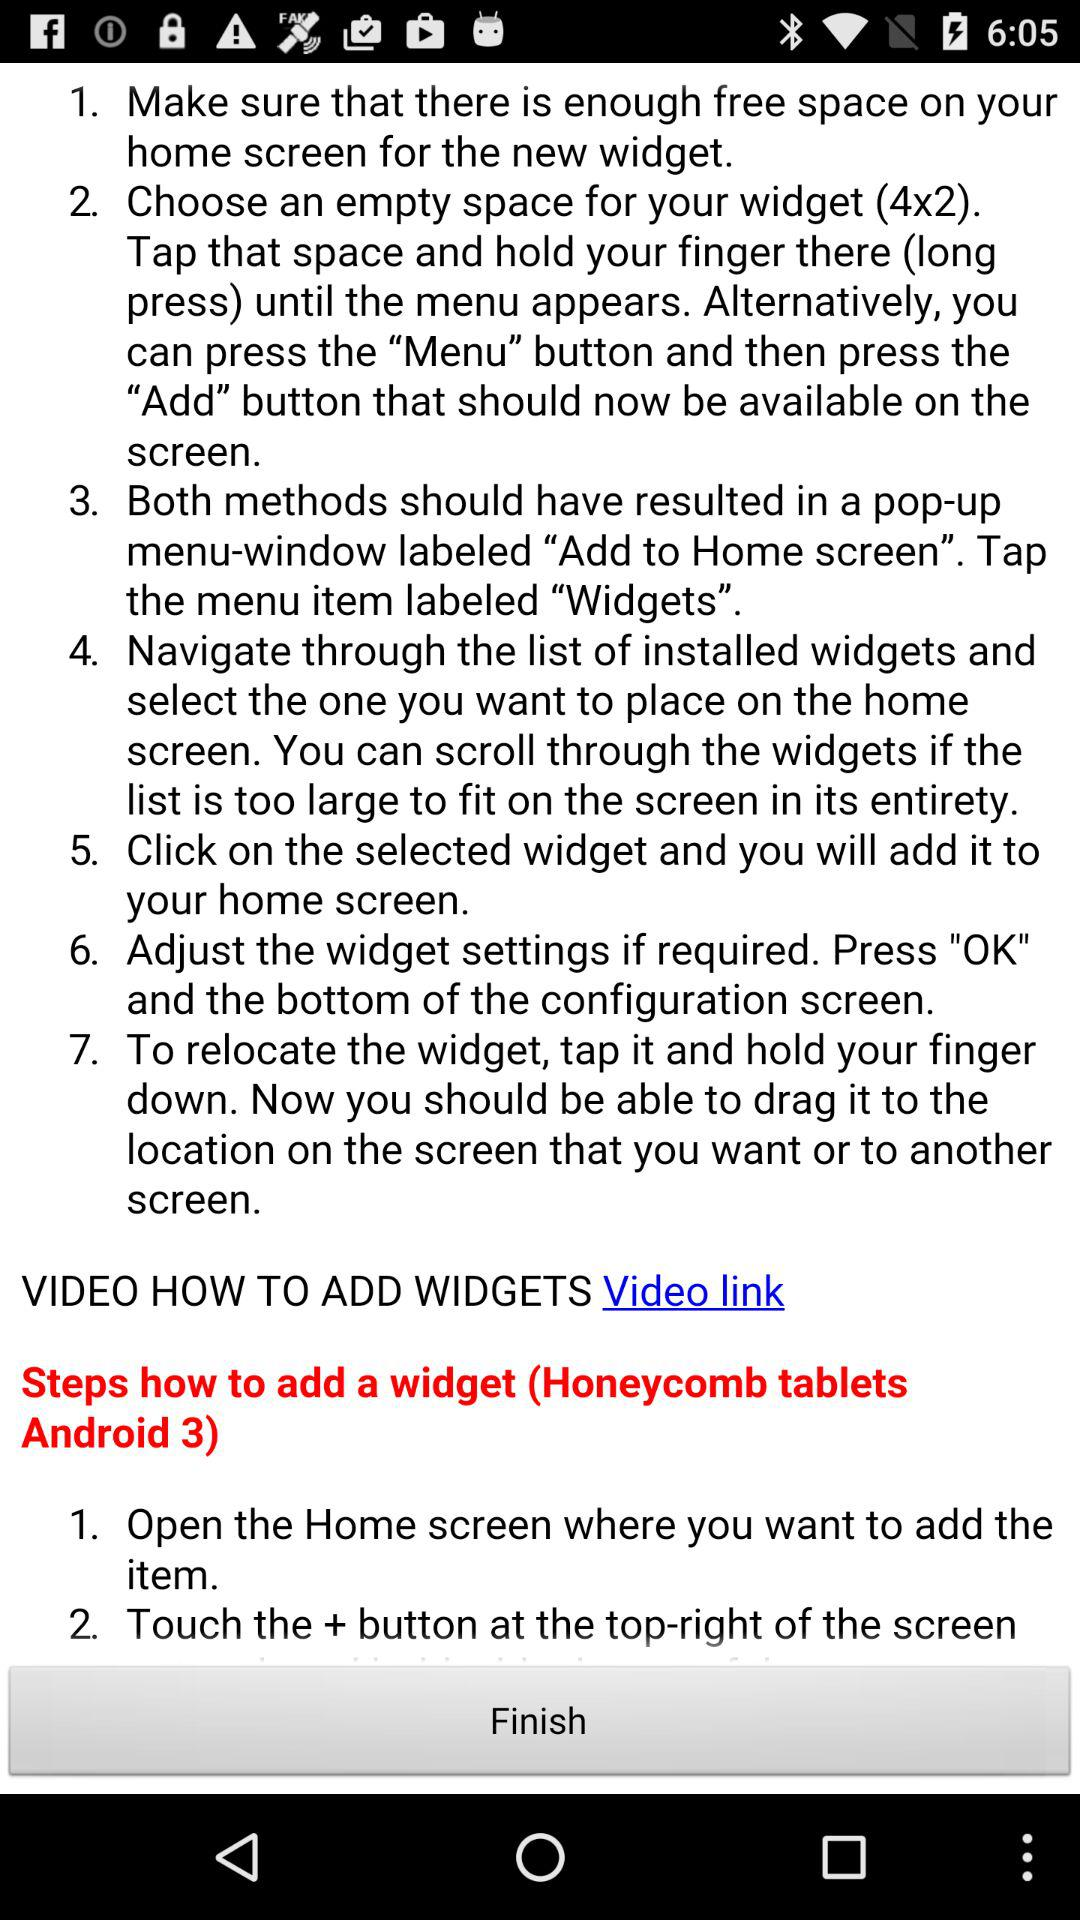What is the name of the Android version for tablets? The name of the Android version for tablets is "Honeycomb". 